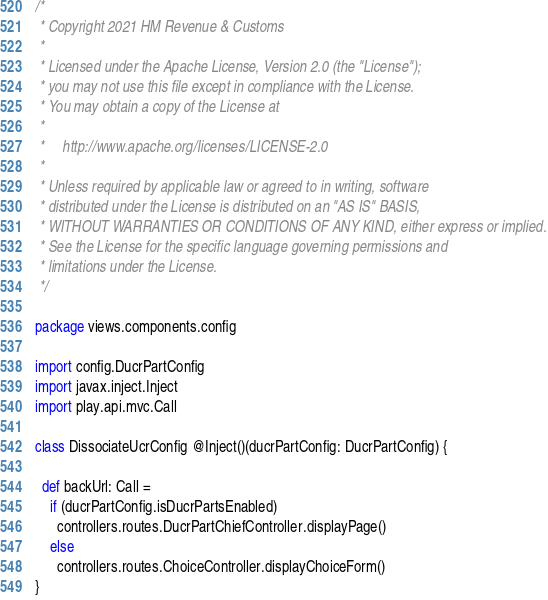Convert code to text. <code><loc_0><loc_0><loc_500><loc_500><_Scala_>/*
 * Copyright 2021 HM Revenue & Customs
 *
 * Licensed under the Apache License, Version 2.0 (the "License");
 * you may not use this file except in compliance with the License.
 * You may obtain a copy of the License at
 *
 *     http://www.apache.org/licenses/LICENSE-2.0
 *
 * Unless required by applicable law or agreed to in writing, software
 * distributed under the License is distributed on an "AS IS" BASIS,
 * WITHOUT WARRANTIES OR CONDITIONS OF ANY KIND, either express or implied.
 * See the License for the specific language governing permissions and
 * limitations under the License.
 */

package views.components.config

import config.DucrPartConfig
import javax.inject.Inject
import play.api.mvc.Call

class DissociateUcrConfig @Inject()(ducrPartConfig: DucrPartConfig) {

  def backUrl: Call =
    if (ducrPartConfig.isDucrPartsEnabled)
      controllers.routes.DucrPartChiefController.displayPage()
    else
      controllers.routes.ChoiceController.displayChoiceForm()
}
</code> 